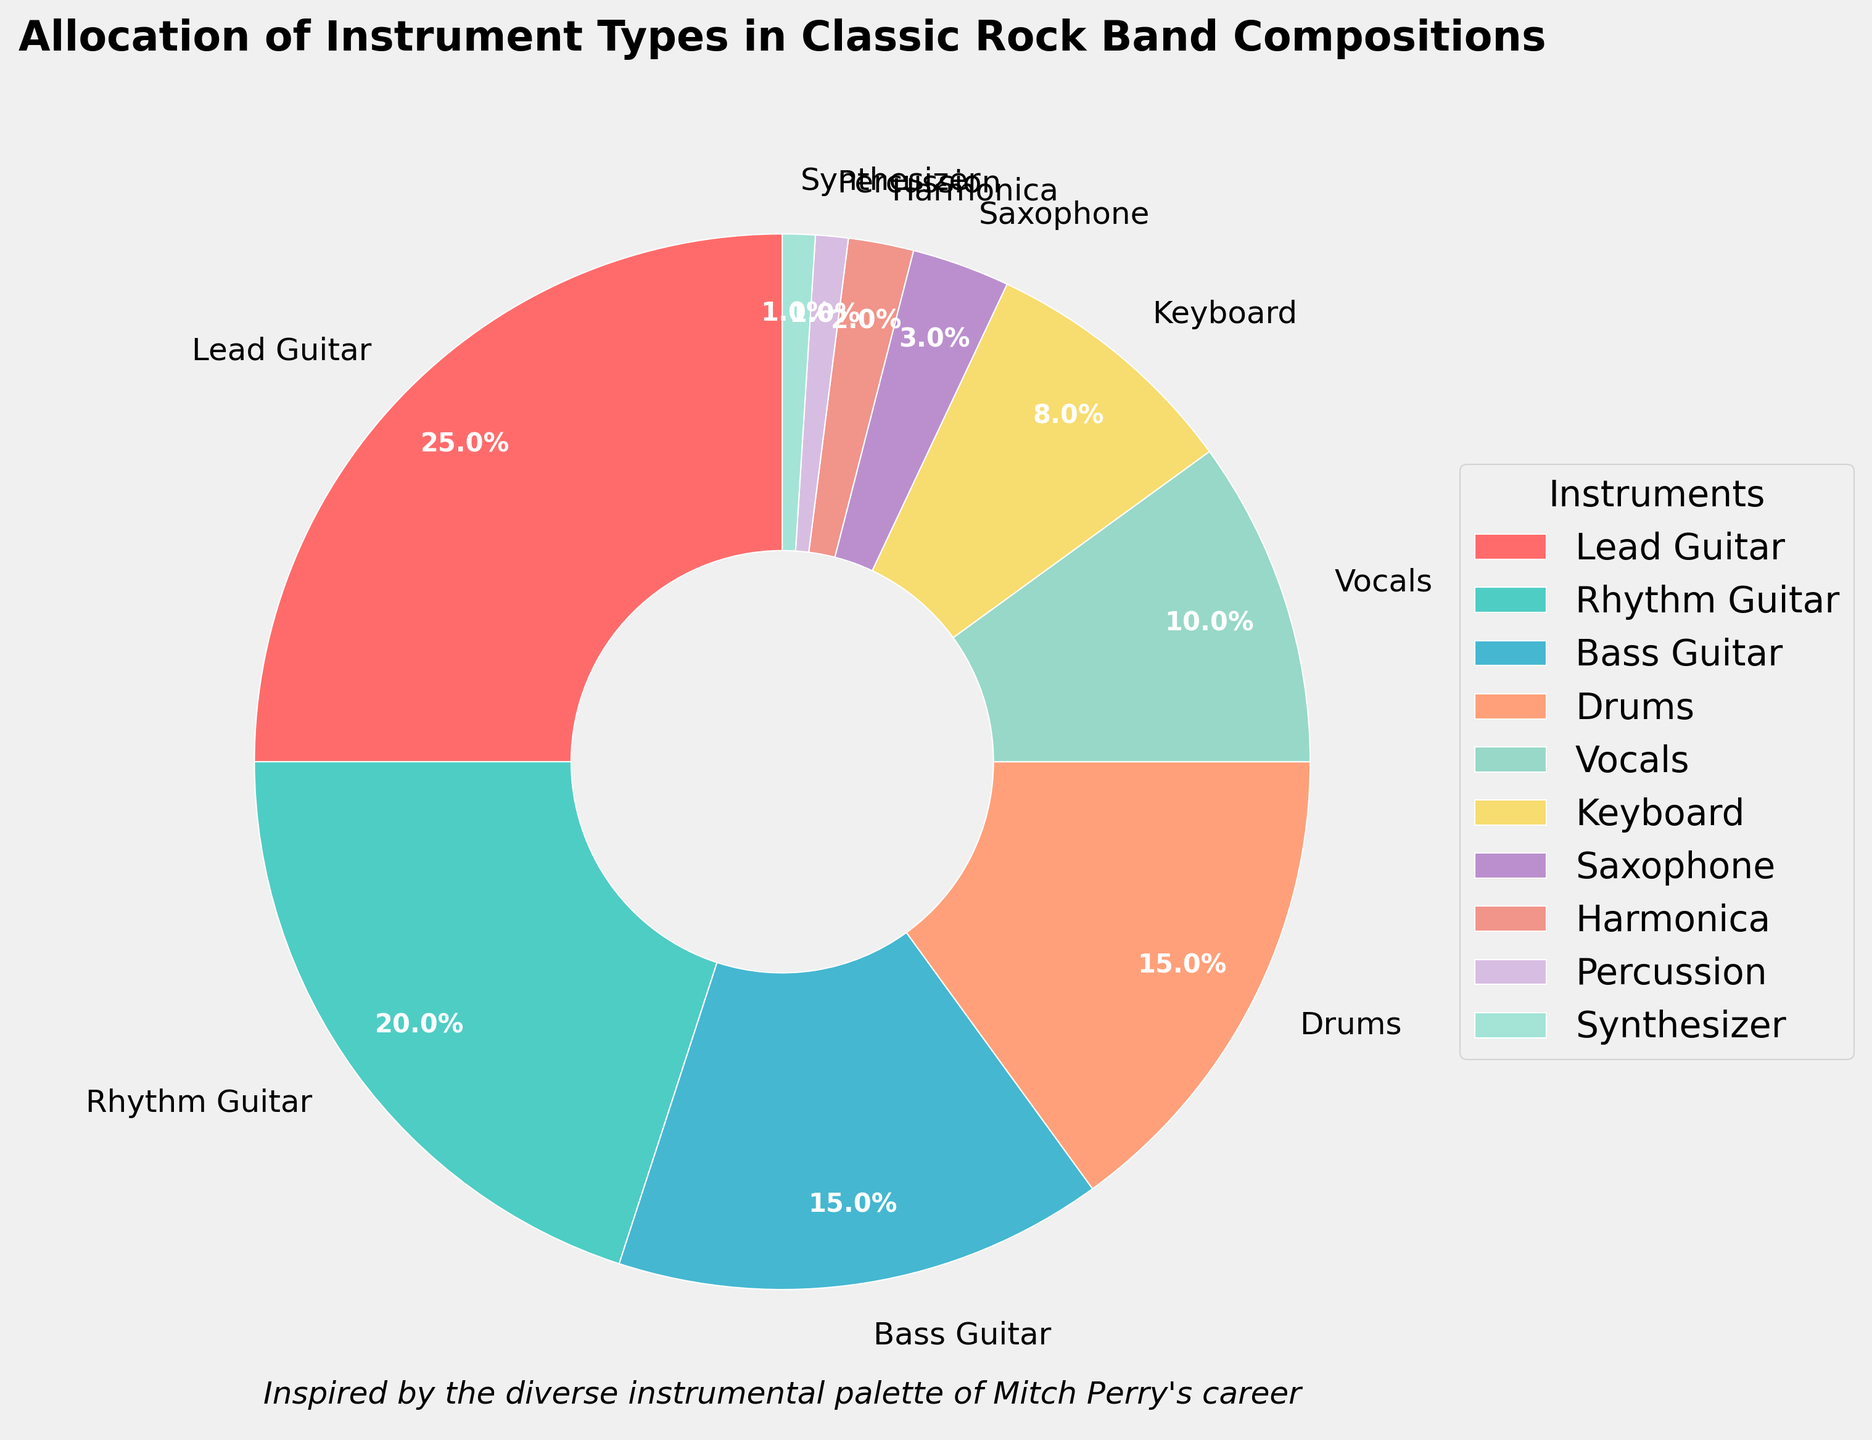What is the percentage allocation of the Lead Guitar? The chart shows that Lead Guitar has a percentage allocation of 25%, as indicated by the label on the Lead Guitar segment.
Answer: 25% Which instrument has the smallest percentage allocation? The chart shows that Synthesizer has a 1% allocation, which is the smallest compared to all other instrument segments.
Answer: Synthesizer How much larger is the allocation for Drums compared to Harmonica? Drums have a 15% allocation, and Harmonica has a 2% allocation. The difference is calculated as 15% - 2% = 13%.
Answer: 13% What is the combined percentage of Rhythm Guitar and Bass Guitar? Rhythm Guitar has a 20% allocation, and Bass Guitar has a 15% allocation. Adding these together gives 20% + 15% = 35%.
Answer: 35% Which instruments together make up at least half of the composition? Lead Guitar (25%), Rhythm Guitar (20%), and Bass Guitar (15%) combined make up 25% + 20% + 15% = 60%, which is more than half.
Answer: Lead Guitar, Rhythm Guitar, Bass Guitar Is the allocation of Vocals higher or lower than the allocation of Keyboard? Vocals have a 10% allocation, whereas Keyboard has an 8% allocation, so the allocation of Vocals is higher.
Answer: Higher What is the average percentage allocation of Drums, Percussion, and Synthesizer? The allocations are Drums (15%), Percussion (1%), and Synthesizer (1%). The average is calculated as (15% + 1% + 1%) / 3 = 17% / 3 ≈ 5.67%.
Answer: 5.67% Is the combined allocation of Saxophone and Harmonica greater than that of Vocals? Saxophone has a 3% allocation, Harmonica has a 2% allocation, combined they are 3% + 2% = 5%, which is less than the 10% allocation of Vocals.
Answer: No How does the allocation of Lead Guitar compare to the combined allocation of Vocals and Keyboard? Lead Guitar has a 25% allocation. Vocals (10%) and Keyboard (8%) combined are 10% + 8% = 18%. Lead Guitar's allocation is higher.
Answer: Higher Which instrument has the highest percentage allocation? The chart shows that Lead Guitar has the highest percentage allocation of 25%.
Answer: Lead Guitar 